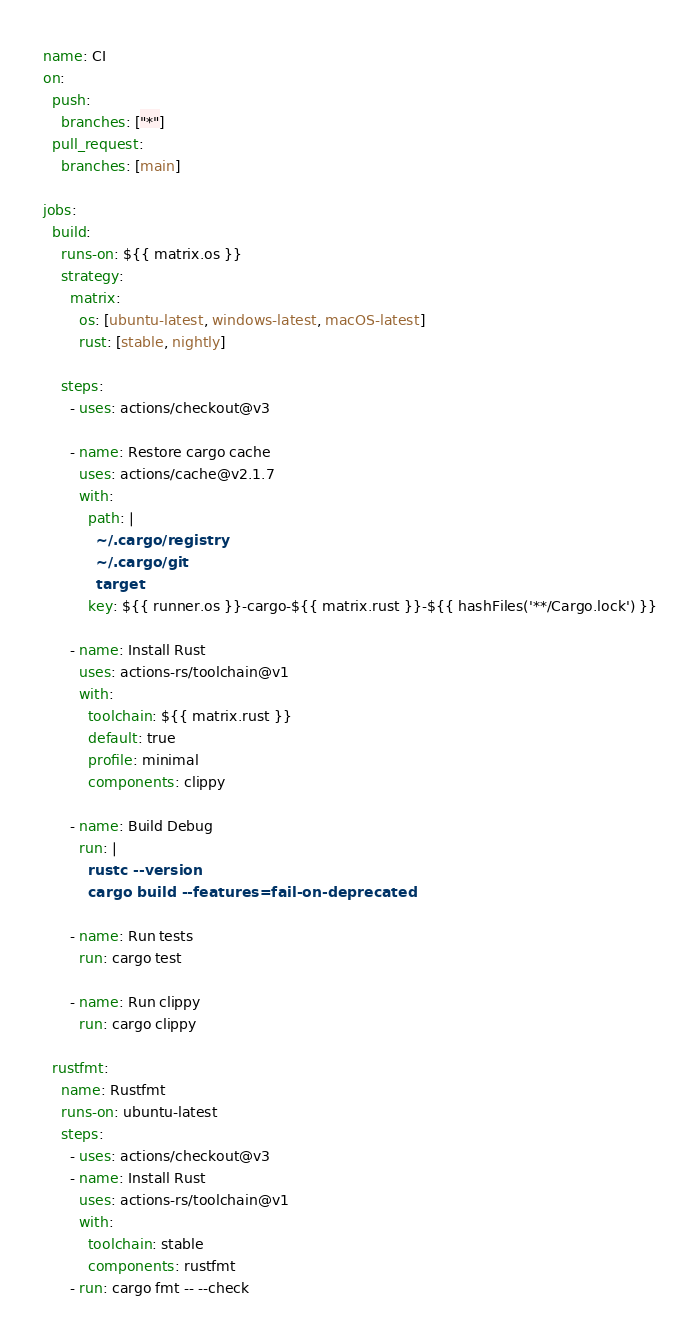Convert code to text. <code><loc_0><loc_0><loc_500><loc_500><_YAML_>name: CI
on:
  push:
    branches: ["*"]
  pull_request:
    branches: [main]

jobs:
  build:
    runs-on: ${{ matrix.os }}
    strategy:
      matrix:
        os: [ubuntu-latest, windows-latest, macOS-latest]
        rust: [stable, nightly]

    steps:
      - uses: actions/checkout@v3

      - name: Restore cargo cache
        uses: actions/cache@v2.1.7
        with:
          path: |
            ~/.cargo/registry
            ~/.cargo/git
            target
          key: ${{ runner.os }}-cargo-${{ matrix.rust }}-${{ hashFiles('**/Cargo.lock') }}

      - name: Install Rust
        uses: actions-rs/toolchain@v1
        with:
          toolchain: ${{ matrix.rust }}
          default: true
          profile: minimal
          components: clippy

      - name: Build Debug
        run: |
          rustc --version
          cargo build --features=fail-on-deprecated

      - name: Run tests
        run: cargo test

      - name: Run clippy
        run: cargo clippy

  rustfmt:
    name: Rustfmt
    runs-on: ubuntu-latest
    steps:
      - uses: actions/checkout@v3
      - name: Install Rust
        uses: actions-rs/toolchain@v1
        with:
          toolchain: stable
          components: rustfmt
      - run: cargo fmt -- --check
</code> 